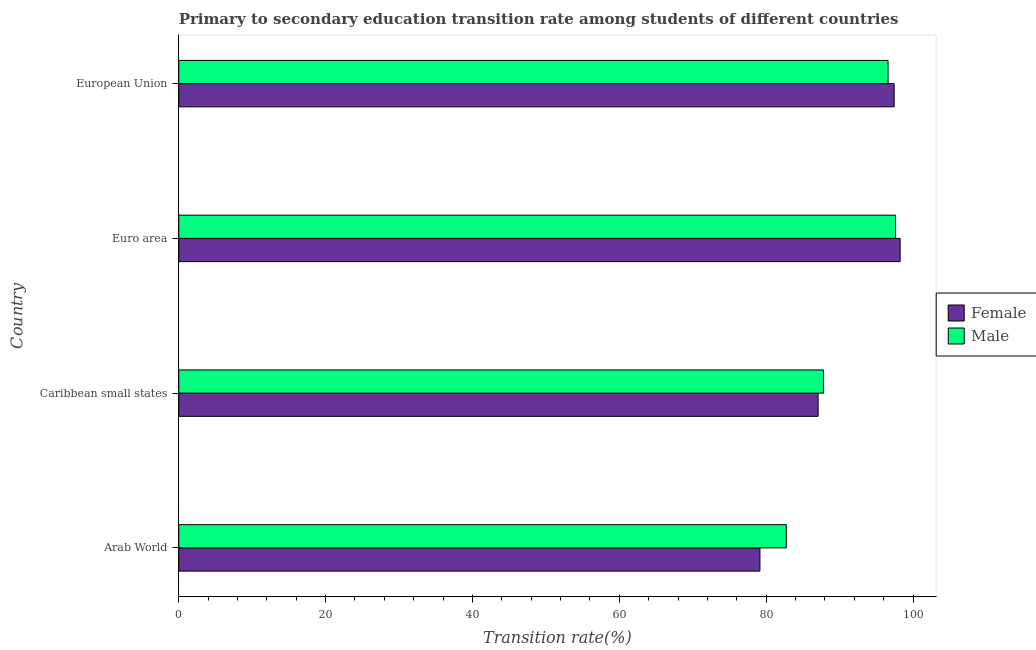How many groups of bars are there?
Provide a short and direct response. 4. Are the number of bars per tick equal to the number of legend labels?
Provide a succinct answer. Yes. How many bars are there on the 4th tick from the top?
Provide a succinct answer. 2. What is the transition rate among male students in Caribbean small states?
Make the answer very short. 87.8. Across all countries, what is the maximum transition rate among male students?
Give a very brief answer. 97.62. Across all countries, what is the minimum transition rate among female students?
Give a very brief answer. 79.15. In which country was the transition rate among male students maximum?
Offer a terse response. Euro area. In which country was the transition rate among male students minimum?
Ensure brevity in your answer.  Arab World. What is the total transition rate among female students in the graph?
Give a very brief answer. 361.9. What is the difference between the transition rate among male students in Caribbean small states and that in European Union?
Offer a terse response. -8.8. What is the difference between the transition rate among male students in Caribbean small states and the transition rate among female students in European Union?
Provide a succinct answer. -9.63. What is the average transition rate among female students per country?
Provide a succinct answer. 90.47. What is the difference between the transition rate among male students and transition rate among female students in European Union?
Your answer should be compact. -0.83. What is the ratio of the transition rate among female students in Arab World to that in Caribbean small states?
Give a very brief answer. 0.91. Is the difference between the transition rate among female students in Arab World and Caribbean small states greater than the difference between the transition rate among male students in Arab World and Caribbean small states?
Provide a succinct answer. No. What is the difference between the highest and the lowest transition rate among male students?
Your answer should be very brief. 14.87. Is the sum of the transition rate among female students in Arab World and Caribbean small states greater than the maximum transition rate among male students across all countries?
Your answer should be very brief. Yes. What does the 2nd bar from the top in Caribbean small states represents?
Provide a succinct answer. Female. What does the 1st bar from the bottom in Arab World represents?
Provide a short and direct response. Female. Are all the bars in the graph horizontal?
Your response must be concise. Yes. Does the graph contain any zero values?
Your answer should be compact. No. Does the graph contain grids?
Ensure brevity in your answer.  No. How many legend labels are there?
Offer a terse response. 2. What is the title of the graph?
Your answer should be very brief. Primary to secondary education transition rate among students of different countries. What is the label or title of the X-axis?
Your response must be concise. Transition rate(%). What is the Transition rate(%) of Female in Arab World?
Provide a short and direct response. 79.15. What is the Transition rate(%) in Male in Arab World?
Keep it short and to the point. 82.75. What is the Transition rate(%) of Female in Caribbean small states?
Keep it short and to the point. 87.07. What is the Transition rate(%) in Male in Caribbean small states?
Keep it short and to the point. 87.8. What is the Transition rate(%) of Female in Euro area?
Your answer should be compact. 98.24. What is the Transition rate(%) in Male in Euro area?
Your answer should be very brief. 97.62. What is the Transition rate(%) in Female in European Union?
Keep it short and to the point. 97.43. What is the Transition rate(%) in Male in European Union?
Provide a short and direct response. 96.6. Across all countries, what is the maximum Transition rate(%) in Female?
Provide a succinct answer. 98.24. Across all countries, what is the maximum Transition rate(%) of Male?
Ensure brevity in your answer.  97.62. Across all countries, what is the minimum Transition rate(%) of Female?
Make the answer very short. 79.15. Across all countries, what is the minimum Transition rate(%) in Male?
Provide a succinct answer. 82.75. What is the total Transition rate(%) in Female in the graph?
Keep it short and to the point. 361.9. What is the total Transition rate(%) of Male in the graph?
Your answer should be compact. 364.77. What is the difference between the Transition rate(%) in Female in Arab World and that in Caribbean small states?
Your response must be concise. -7.92. What is the difference between the Transition rate(%) in Male in Arab World and that in Caribbean small states?
Offer a very short reply. -5.05. What is the difference between the Transition rate(%) in Female in Arab World and that in Euro area?
Make the answer very short. -19.09. What is the difference between the Transition rate(%) of Male in Arab World and that in Euro area?
Your answer should be very brief. -14.87. What is the difference between the Transition rate(%) in Female in Arab World and that in European Union?
Make the answer very short. -18.28. What is the difference between the Transition rate(%) in Male in Arab World and that in European Union?
Offer a terse response. -13.85. What is the difference between the Transition rate(%) of Female in Caribbean small states and that in Euro area?
Your response must be concise. -11.17. What is the difference between the Transition rate(%) of Male in Caribbean small states and that in Euro area?
Ensure brevity in your answer.  -9.82. What is the difference between the Transition rate(%) of Female in Caribbean small states and that in European Union?
Provide a short and direct response. -10.36. What is the difference between the Transition rate(%) in Male in Caribbean small states and that in European Union?
Offer a terse response. -8.8. What is the difference between the Transition rate(%) of Female in Euro area and that in European Union?
Provide a short and direct response. 0.81. What is the difference between the Transition rate(%) in Male in Euro area and that in European Union?
Your answer should be compact. 1.02. What is the difference between the Transition rate(%) of Female in Arab World and the Transition rate(%) of Male in Caribbean small states?
Your answer should be very brief. -8.65. What is the difference between the Transition rate(%) in Female in Arab World and the Transition rate(%) in Male in Euro area?
Offer a very short reply. -18.47. What is the difference between the Transition rate(%) in Female in Arab World and the Transition rate(%) in Male in European Union?
Give a very brief answer. -17.45. What is the difference between the Transition rate(%) of Female in Caribbean small states and the Transition rate(%) of Male in Euro area?
Keep it short and to the point. -10.55. What is the difference between the Transition rate(%) of Female in Caribbean small states and the Transition rate(%) of Male in European Union?
Offer a terse response. -9.53. What is the difference between the Transition rate(%) of Female in Euro area and the Transition rate(%) of Male in European Union?
Provide a short and direct response. 1.64. What is the average Transition rate(%) of Female per country?
Offer a very short reply. 90.47. What is the average Transition rate(%) in Male per country?
Ensure brevity in your answer.  91.19. What is the difference between the Transition rate(%) of Female and Transition rate(%) of Male in Arab World?
Offer a terse response. -3.6. What is the difference between the Transition rate(%) in Female and Transition rate(%) in Male in Caribbean small states?
Keep it short and to the point. -0.73. What is the difference between the Transition rate(%) of Female and Transition rate(%) of Male in Euro area?
Your answer should be compact. 0.62. What is the difference between the Transition rate(%) in Female and Transition rate(%) in Male in European Union?
Offer a terse response. 0.83. What is the ratio of the Transition rate(%) in Female in Arab World to that in Caribbean small states?
Provide a short and direct response. 0.91. What is the ratio of the Transition rate(%) of Male in Arab World to that in Caribbean small states?
Your answer should be very brief. 0.94. What is the ratio of the Transition rate(%) in Female in Arab World to that in Euro area?
Provide a short and direct response. 0.81. What is the ratio of the Transition rate(%) in Male in Arab World to that in Euro area?
Your response must be concise. 0.85. What is the ratio of the Transition rate(%) in Female in Arab World to that in European Union?
Offer a very short reply. 0.81. What is the ratio of the Transition rate(%) of Male in Arab World to that in European Union?
Your answer should be compact. 0.86. What is the ratio of the Transition rate(%) in Female in Caribbean small states to that in Euro area?
Offer a very short reply. 0.89. What is the ratio of the Transition rate(%) of Male in Caribbean small states to that in Euro area?
Provide a short and direct response. 0.9. What is the ratio of the Transition rate(%) in Female in Caribbean small states to that in European Union?
Your answer should be very brief. 0.89. What is the ratio of the Transition rate(%) in Male in Caribbean small states to that in European Union?
Provide a short and direct response. 0.91. What is the ratio of the Transition rate(%) in Female in Euro area to that in European Union?
Ensure brevity in your answer.  1.01. What is the ratio of the Transition rate(%) in Male in Euro area to that in European Union?
Your answer should be compact. 1.01. What is the difference between the highest and the second highest Transition rate(%) in Female?
Make the answer very short. 0.81. What is the difference between the highest and the second highest Transition rate(%) of Male?
Keep it short and to the point. 1.02. What is the difference between the highest and the lowest Transition rate(%) in Female?
Ensure brevity in your answer.  19.09. What is the difference between the highest and the lowest Transition rate(%) of Male?
Keep it short and to the point. 14.87. 